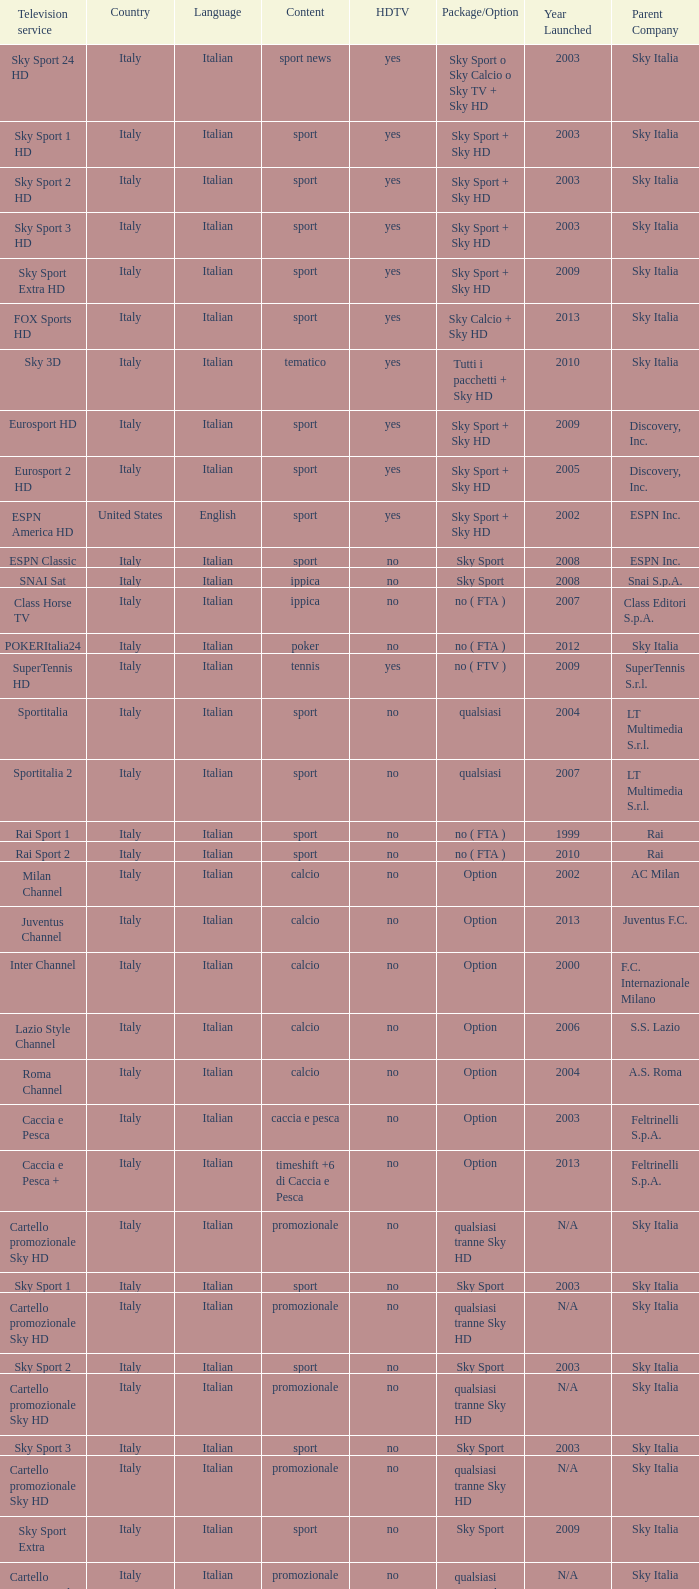What is the nation when the tv service is eurosport 2? Italy. 